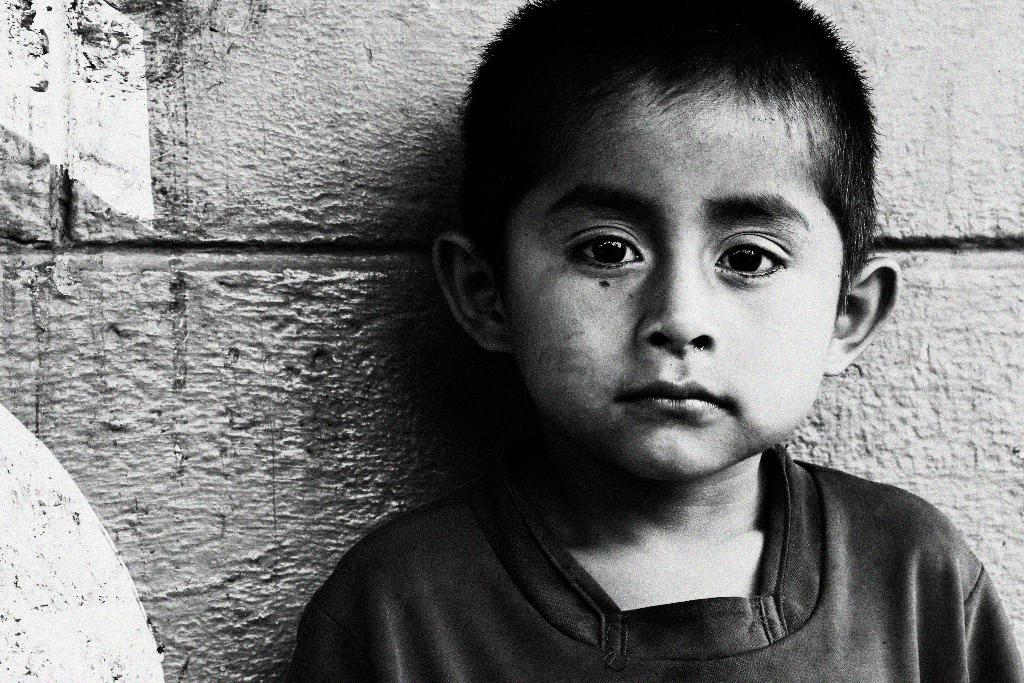What is the color scheme of the image? The image is black and white. Who is present in the image? There is a boy in the image. What can be seen in the background of the image? There is a wall in the background of the image. Can you see any books or a library in the image? There is no mention of books or a library in the image; it only features a boy and a wall in the background. 